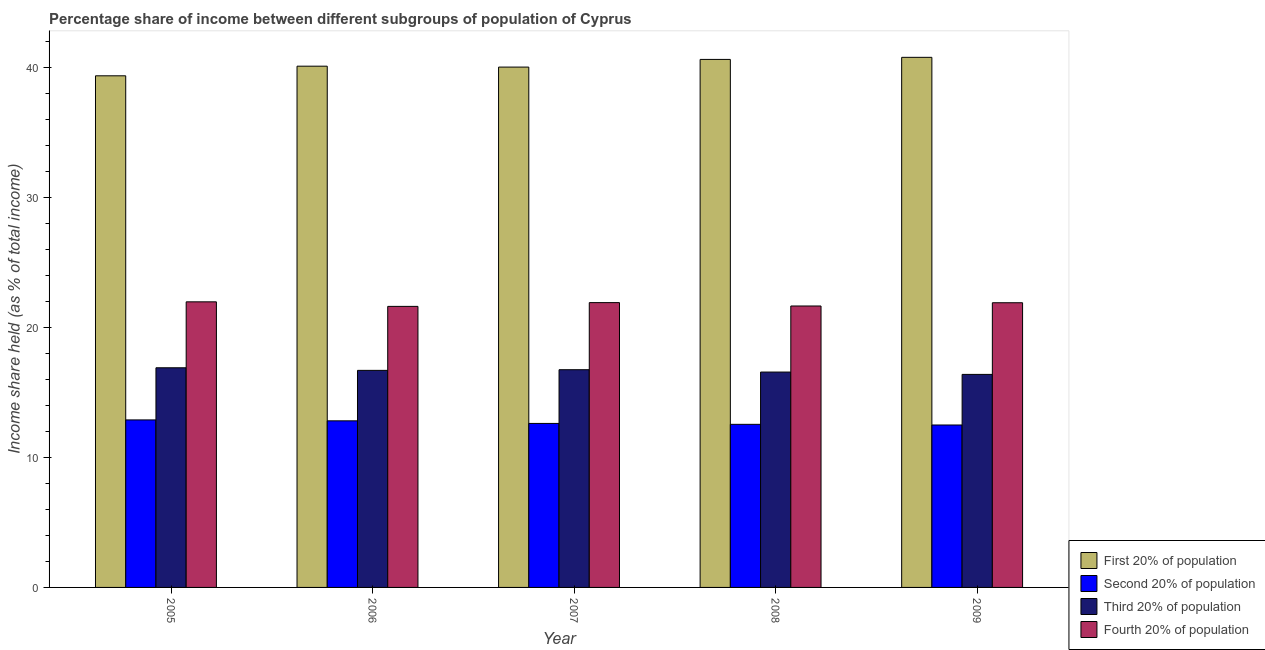How many groups of bars are there?
Give a very brief answer. 5. Are the number of bars on each tick of the X-axis equal?
Offer a terse response. Yes. How many bars are there on the 1st tick from the left?
Your response must be concise. 4. In how many cases, is the number of bars for a given year not equal to the number of legend labels?
Offer a terse response. 0. What is the share of the income held by fourth 20% of the population in 2009?
Provide a succinct answer. 21.89. Across all years, what is the maximum share of the income held by second 20% of the population?
Offer a very short reply. 12.88. Across all years, what is the minimum share of the income held by third 20% of the population?
Keep it short and to the point. 16.38. In which year was the share of the income held by third 20% of the population maximum?
Your answer should be compact. 2005. In which year was the share of the income held by third 20% of the population minimum?
Provide a succinct answer. 2009. What is the total share of the income held by second 20% of the population in the graph?
Your answer should be very brief. 63.33. What is the difference between the share of the income held by third 20% of the population in 2006 and that in 2008?
Your response must be concise. 0.13. What is the difference between the share of the income held by second 20% of the population in 2005 and the share of the income held by third 20% of the population in 2009?
Provide a succinct answer. 0.39. What is the average share of the income held by fourth 20% of the population per year?
Make the answer very short. 21.8. In the year 2007, what is the difference between the share of the income held by fourth 20% of the population and share of the income held by third 20% of the population?
Your answer should be very brief. 0. In how many years, is the share of the income held by first 20% of the population greater than 38 %?
Provide a short and direct response. 5. What is the ratio of the share of the income held by second 20% of the population in 2006 to that in 2008?
Provide a succinct answer. 1.02. Is the difference between the share of the income held by second 20% of the population in 2005 and 2008 greater than the difference between the share of the income held by first 20% of the population in 2005 and 2008?
Give a very brief answer. No. What is the difference between the highest and the second highest share of the income held by third 20% of the population?
Ensure brevity in your answer.  0.15. What is the difference between the highest and the lowest share of the income held by first 20% of the population?
Your answer should be very brief. 1.42. In how many years, is the share of the income held by fourth 20% of the population greater than the average share of the income held by fourth 20% of the population taken over all years?
Your answer should be very brief. 3. Is it the case that in every year, the sum of the share of the income held by first 20% of the population and share of the income held by second 20% of the population is greater than the sum of share of the income held by fourth 20% of the population and share of the income held by third 20% of the population?
Make the answer very short. Yes. What does the 2nd bar from the left in 2005 represents?
Provide a succinct answer. Second 20% of population. What does the 1st bar from the right in 2005 represents?
Keep it short and to the point. Fourth 20% of population. What is the difference between two consecutive major ticks on the Y-axis?
Offer a terse response. 10. Are the values on the major ticks of Y-axis written in scientific E-notation?
Your answer should be very brief. No. Does the graph contain any zero values?
Give a very brief answer. No. Does the graph contain grids?
Provide a short and direct response. No. Where does the legend appear in the graph?
Offer a very short reply. Bottom right. How are the legend labels stacked?
Offer a terse response. Vertical. What is the title of the graph?
Ensure brevity in your answer.  Percentage share of income between different subgroups of population of Cyprus. What is the label or title of the Y-axis?
Provide a short and direct response. Income share held (as % of total income). What is the Income share held (as % of total income) in First 20% of population in 2005?
Your answer should be very brief. 39.34. What is the Income share held (as % of total income) of Second 20% of population in 2005?
Provide a short and direct response. 12.88. What is the Income share held (as % of total income) of Third 20% of population in 2005?
Your answer should be compact. 16.89. What is the Income share held (as % of total income) of Fourth 20% of population in 2005?
Keep it short and to the point. 21.96. What is the Income share held (as % of total income) of First 20% of population in 2006?
Offer a very short reply. 40.08. What is the Income share held (as % of total income) in Second 20% of population in 2006?
Make the answer very short. 12.81. What is the Income share held (as % of total income) in Third 20% of population in 2006?
Keep it short and to the point. 16.69. What is the Income share held (as % of total income) in Fourth 20% of population in 2006?
Offer a very short reply. 21.61. What is the Income share held (as % of total income) in First 20% of population in 2007?
Your answer should be compact. 40.01. What is the Income share held (as % of total income) in Second 20% of population in 2007?
Offer a terse response. 12.61. What is the Income share held (as % of total income) in Third 20% of population in 2007?
Give a very brief answer. 16.74. What is the Income share held (as % of total income) of Fourth 20% of population in 2007?
Provide a short and direct response. 21.9. What is the Income share held (as % of total income) in First 20% of population in 2008?
Offer a very short reply. 40.6. What is the Income share held (as % of total income) in Second 20% of population in 2008?
Provide a succinct answer. 12.54. What is the Income share held (as % of total income) in Third 20% of population in 2008?
Give a very brief answer. 16.56. What is the Income share held (as % of total income) in Fourth 20% of population in 2008?
Provide a succinct answer. 21.64. What is the Income share held (as % of total income) of First 20% of population in 2009?
Provide a short and direct response. 40.76. What is the Income share held (as % of total income) in Second 20% of population in 2009?
Offer a very short reply. 12.49. What is the Income share held (as % of total income) in Third 20% of population in 2009?
Ensure brevity in your answer.  16.38. What is the Income share held (as % of total income) in Fourth 20% of population in 2009?
Keep it short and to the point. 21.89. Across all years, what is the maximum Income share held (as % of total income) in First 20% of population?
Keep it short and to the point. 40.76. Across all years, what is the maximum Income share held (as % of total income) in Second 20% of population?
Provide a succinct answer. 12.88. Across all years, what is the maximum Income share held (as % of total income) in Third 20% of population?
Your response must be concise. 16.89. Across all years, what is the maximum Income share held (as % of total income) of Fourth 20% of population?
Your answer should be compact. 21.96. Across all years, what is the minimum Income share held (as % of total income) in First 20% of population?
Your answer should be very brief. 39.34. Across all years, what is the minimum Income share held (as % of total income) in Second 20% of population?
Your answer should be compact. 12.49. Across all years, what is the minimum Income share held (as % of total income) of Third 20% of population?
Offer a very short reply. 16.38. Across all years, what is the minimum Income share held (as % of total income) in Fourth 20% of population?
Your response must be concise. 21.61. What is the total Income share held (as % of total income) of First 20% of population in the graph?
Your answer should be very brief. 200.79. What is the total Income share held (as % of total income) of Second 20% of population in the graph?
Offer a terse response. 63.33. What is the total Income share held (as % of total income) in Third 20% of population in the graph?
Your answer should be very brief. 83.26. What is the total Income share held (as % of total income) in Fourth 20% of population in the graph?
Your answer should be compact. 109. What is the difference between the Income share held (as % of total income) in First 20% of population in 2005 and that in 2006?
Offer a terse response. -0.74. What is the difference between the Income share held (as % of total income) in Second 20% of population in 2005 and that in 2006?
Your answer should be compact. 0.07. What is the difference between the Income share held (as % of total income) of Third 20% of population in 2005 and that in 2006?
Keep it short and to the point. 0.2. What is the difference between the Income share held (as % of total income) of Fourth 20% of population in 2005 and that in 2006?
Your answer should be compact. 0.35. What is the difference between the Income share held (as % of total income) of First 20% of population in 2005 and that in 2007?
Offer a terse response. -0.67. What is the difference between the Income share held (as % of total income) of Second 20% of population in 2005 and that in 2007?
Offer a very short reply. 0.27. What is the difference between the Income share held (as % of total income) in Fourth 20% of population in 2005 and that in 2007?
Offer a very short reply. 0.06. What is the difference between the Income share held (as % of total income) in First 20% of population in 2005 and that in 2008?
Your answer should be very brief. -1.26. What is the difference between the Income share held (as % of total income) of Second 20% of population in 2005 and that in 2008?
Keep it short and to the point. 0.34. What is the difference between the Income share held (as % of total income) in Third 20% of population in 2005 and that in 2008?
Provide a short and direct response. 0.33. What is the difference between the Income share held (as % of total income) in Fourth 20% of population in 2005 and that in 2008?
Offer a terse response. 0.32. What is the difference between the Income share held (as % of total income) in First 20% of population in 2005 and that in 2009?
Offer a terse response. -1.42. What is the difference between the Income share held (as % of total income) of Second 20% of population in 2005 and that in 2009?
Your response must be concise. 0.39. What is the difference between the Income share held (as % of total income) in Third 20% of population in 2005 and that in 2009?
Provide a short and direct response. 0.51. What is the difference between the Income share held (as % of total income) of Fourth 20% of population in 2005 and that in 2009?
Give a very brief answer. 0.07. What is the difference between the Income share held (as % of total income) of First 20% of population in 2006 and that in 2007?
Offer a terse response. 0.07. What is the difference between the Income share held (as % of total income) in Second 20% of population in 2006 and that in 2007?
Your answer should be very brief. 0.2. What is the difference between the Income share held (as % of total income) in Third 20% of population in 2006 and that in 2007?
Provide a short and direct response. -0.05. What is the difference between the Income share held (as % of total income) in Fourth 20% of population in 2006 and that in 2007?
Ensure brevity in your answer.  -0.29. What is the difference between the Income share held (as % of total income) in First 20% of population in 2006 and that in 2008?
Your answer should be compact. -0.52. What is the difference between the Income share held (as % of total income) in Second 20% of population in 2006 and that in 2008?
Offer a terse response. 0.27. What is the difference between the Income share held (as % of total income) of Third 20% of population in 2006 and that in 2008?
Give a very brief answer. 0.13. What is the difference between the Income share held (as % of total income) in Fourth 20% of population in 2006 and that in 2008?
Offer a terse response. -0.03. What is the difference between the Income share held (as % of total income) in First 20% of population in 2006 and that in 2009?
Your answer should be compact. -0.68. What is the difference between the Income share held (as % of total income) in Second 20% of population in 2006 and that in 2009?
Make the answer very short. 0.32. What is the difference between the Income share held (as % of total income) in Third 20% of population in 2006 and that in 2009?
Make the answer very short. 0.31. What is the difference between the Income share held (as % of total income) of Fourth 20% of population in 2006 and that in 2009?
Keep it short and to the point. -0.28. What is the difference between the Income share held (as % of total income) of First 20% of population in 2007 and that in 2008?
Your answer should be very brief. -0.59. What is the difference between the Income share held (as % of total income) in Second 20% of population in 2007 and that in 2008?
Offer a terse response. 0.07. What is the difference between the Income share held (as % of total income) in Third 20% of population in 2007 and that in 2008?
Ensure brevity in your answer.  0.18. What is the difference between the Income share held (as % of total income) of Fourth 20% of population in 2007 and that in 2008?
Keep it short and to the point. 0.26. What is the difference between the Income share held (as % of total income) of First 20% of population in 2007 and that in 2009?
Your answer should be compact. -0.75. What is the difference between the Income share held (as % of total income) in Second 20% of population in 2007 and that in 2009?
Provide a succinct answer. 0.12. What is the difference between the Income share held (as % of total income) of Third 20% of population in 2007 and that in 2009?
Provide a short and direct response. 0.36. What is the difference between the Income share held (as % of total income) of Fourth 20% of population in 2007 and that in 2009?
Provide a succinct answer. 0.01. What is the difference between the Income share held (as % of total income) in First 20% of population in 2008 and that in 2009?
Make the answer very short. -0.16. What is the difference between the Income share held (as % of total income) in Third 20% of population in 2008 and that in 2009?
Your answer should be compact. 0.18. What is the difference between the Income share held (as % of total income) of Fourth 20% of population in 2008 and that in 2009?
Give a very brief answer. -0.25. What is the difference between the Income share held (as % of total income) of First 20% of population in 2005 and the Income share held (as % of total income) of Second 20% of population in 2006?
Offer a terse response. 26.53. What is the difference between the Income share held (as % of total income) in First 20% of population in 2005 and the Income share held (as % of total income) in Third 20% of population in 2006?
Your answer should be compact. 22.65. What is the difference between the Income share held (as % of total income) in First 20% of population in 2005 and the Income share held (as % of total income) in Fourth 20% of population in 2006?
Keep it short and to the point. 17.73. What is the difference between the Income share held (as % of total income) of Second 20% of population in 2005 and the Income share held (as % of total income) of Third 20% of population in 2006?
Offer a terse response. -3.81. What is the difference between the Income share held (as % of total income) in Second 20% of population in 2005 and the Income share held (as % of total income) in Fourth 20% of population in 2006?
Give a very brief answer. -8.73. What is the difference between the Income share held (as % of total income) in Third 20% of population in 2005 and the Income share held (as % of total income) in Fourth 20% of population in 2006?
Offer a terse response. -4.72. What is the difference between the Income share held (as % of total income) in First 20% of population in 2005 and the Income share held (as % of total income) in Second 20% of population in 2007?
Your answer should be very brief. 26.73. What is the difference between the Income share held (as % of total income) of First 20% of population in 2005 and the Income share held (as % of total income) of Third 20% of population in 2007?
Your answer should be very brief. 22.6. What is the difference between the Income share held (as % of total income) in First 20% of population in 2005 and the Income share held (as % of total income) in Fourth 20% of population in 2007?
Keep it short and to the point. 17.44. What is the difference between the Income share held (as % of total income) of Second 20% of population in 2005 and the Income share held (as % of total income) of Third 20% of population in 2007?
Provide a succinct answer. -3.86. What is the difference between the Income share held (as % of total income) of Second 20% of population in 2005 and the Income share held (as % of total income) of Fourth 20% of population in 2007?
Your answer should be very brief. -9.02. What is the difference between the Income share held (as % of total income) in Third 20% of population in 2005 and the Income share held (as % of total income) in Fourth 20% of population in 2007?
Provide a short and direct response. -5.01. What is the difference between the Income share held (as % of total income) in First 20% of population in 2005 and the Income share held (as % of total income) in Second 20% of population in 2008?
Make the answer very short. 26.8. What is the difference between the Income share held (as % of total income) of First 20% of population in 2005 and the Income share held (as % of total income) of Third 20% of population in 2008?
Keep it short and to the point. 22.78. What is the difference between the Income share held (as % of total income) in Second 20% of population in 2005 and the Income share held (as % of total income) in Third 20% of population in 2008?
Offer a very short reply. -3.68. What is the difference between the Income share held (as % of total income) of Second 20% of population in 2005 and the Income share held (as % of total income) of Fourth 20% of population in 2008?
Keep it short and to the point. -8.76. What is the difference between the Income share held (as % of total income) of Third 20% of population in 2005 and the Income share held (as % of total income) of Fourth 20% of population in 2008?
Offer a very short reply. -4.75. What is the difference between the Income share held (as % of total income) in First 20% of population in 2005 and the Income share held (as % of total income) in Second 20% of population in 2009?
Ensure brevity in your answer.  26.85. What is the difference between the Income share held (as % of total income) of First 20% of population in 2005 and the Income share held (as % of total income) of Third 20% of population in 2009?
Provide a short and direct response. 22.96. What is the difference between the Income share held (as % of total income) in First 20% of population in 2005 and the Income share held (as % of total income) in Fourth 20% of population in 2009?
Your answer should be compact. 17.45. What is the difference between the Income share held (as % of total income) of Second 20% of population in 2005 and the Income share held (as % of total income) of Fourth 20% of population in 2009?
Offer a very short reply. -9.01. What is the difference between the Income share held (as % of total income) of Third 20% of population in 2005 and the Income share held (as % of total income) of Fourth 20% of population in 2009?
Provide a succinct answer. -5. What is the difference between the Income share held (as % of total income) of First 20% of population in 2006 and the Income share held (as % of total income) of Second 20% of population in 2007?
Make the answer very short. 27.47. What is the difference between the Income share held (as % of total income) of First 20% of population in 2006 and the Income share held (as % of total income) of Third 20% of population in 2007?
Offer a terse response. 23.34. What is the difference between the Income share held (as % of total income) of First 20% of population in 2006 and the Income share held (as % of total income) of Fourth 20% of population in 2007?
Provide a succinct answer. 18.18. What is the difference between the Income share held (as % of total income) of Second 20% of population in 2006 and the Income share held (as % of total income) of Third 20% of population in 2007?
Your response must be concise. -3.93. What is the difference between the Income share held (as % of total income) of Second 20% of population in 2006 and the Income share held (as % of total income) of Fourth 20% of population in 2007?
Provide a succinct answer. -9.09. What is the difference between the Income share held (as % of total income) in Third 20% of population in 2006 and the Income share held (as % of total income) in Fourth 20% of population in 2007?
Provide a short and direct response. -5.21. What is the difference between the Income share held (as % of total income) in First 20% of population in 2006 and the Income share held (as % of total income) in Second 20% of population in 2008?
Make the answer very short. 27.54. What is the difference between the Income share held (as % of total income) in First 20% of population in 2006 and the Income share held (as % of total income) in Third 20% of population in 2008?
Make the answer very short. 23.52. What is the difference between the Income share held (as % of total income) in First 20% of population in 2006 and the Income share held (as % of total income) in Fourth 20% of population in 2008?
Provide a succinct answer. 18.44. What is the difference between the Income share held (as % of total income) in Second 20% of population in 2006 and the Income share held (as % of total income) in Third 20% of population in 2008?
Provide a short and direct response. -3.75. What is the difference between the Income share held (as % of total income) in Second 20% of population in 2006 and the Income share held (as % of total income) in Fourth 20% of population in 2008?
Ensure brevity in your answer.  -8.83. What is the difference between the Income share held (as % of total income) of Third 20% of population in 2006 and the Income share held (as % of total income) of Fourth 20% of population in 2008?
Keep it short and to the point. -4.95. What is the difference between the Income share held (as % of total income) of First 20% of population in 2006 and the Income share held (as % of total income) of Second 20% of population in 2009?
Offer a very short reply. 27.59. What is the difference between the Income share held (as % of total income) of First 20% of population in 2006 and the Income share held (as % of total income) of Third 20% of population in 2009?
Ensure brevity in your answer.  23.7. What is the difference between the Income share held (as % of total income) of First 20% of population in 2006 and the Income share held (as % of total income) of Fourth 20% of population in 2009?
Offer a very short reply. 18.19. What is the difference between the Income share held (as % of total income) of Second 20% of population in 2006 and the Income share held (as % of total income) of Third 20% of population in 2009?
Provide a succinct answer. -3.57. What is the difference between the Income share held (as % of total income) in Second 20% of population in 2006 and the Income share held (as % of total income) in Fourth 20% of population in 2009?
Your response must be concise. -9.08. What is the difference between the Income share held (as % of total income) of Third 20% of population in 2006 and the Income share held (as % of total income) of Fourth 20% of population in 2009?
Ensure brevity in your answer.  -5.2. What is the difference between the Income share held (as % of total income) in First 20% of population in 2007 and the Income share held (as % of total income) in Second 20% of population in 2008?
Your answer should be very brief. 27.47. What is the difference between the Income share held (as % of total income) of First 20% of population in 2007 and the Income share held (as % of total income) of Third 20% of population in 2008?
Give a very brief answer. 23.45. What is the difference between the Income share held (as % of total income) in First 20% of population in 2007 and the Income share held (as % of total income) in Fourth 20% of population in 2008?
Provide a succinct answer. 18.37. What is the difference between the Income share held (as % of total income) in Second 20% of population in 2007 and the Income share held (as % of total income) in Third 20% of population in 2008?
Ensure brevity in your answer.  -3.95. What is the difference between the Income share held (as % of total income) of Second 20% of population in 2007 and the Income share held (as % of total income) of Fourth 20% of population in 2008?
Make the answer very short. -9.03. What is the difference between the Income share held (as % of total income) of First 20% of population in 2007 and the Income share held (as % of total income) of Second 20% of population in 2009?
Give a very brief answer. 27.52. What is the difference between the Income share held (as % of total income) of First 20% of population in 2007 and the Income share held (as % of total income) of Third 20% of population in 2009?
Your response must be concise. 23.63. What is the difference between the Income share held (as % of total income) of First 20% of population in 2007 and the Income share held (as % of total income) of Fourth 20% of population in 2009?
Provide a succinct answer. 18.12. What is the difference between the Income share held (as % of total income) of Second 20% of population in 2007 and the Income share held (as % of total income) of Third 20% of population in 2009?
Ensure brevity in your answer.  -3.77. What is the difference between the Income share held (as % of total income) in Second 20% of population in 2007 and the Income share held (as % of total income) in Fourth 20% of population in 2009?
Offer a very short reply. -9.28. What is the difference between the Income share held (as % of total income) in Third 20% of population in 2007 and the Income share held (as % of total income) in Fourth 20% of population in 2009?
Provide a short and direct response. -5.15. What is the difference between the Income share held (as % of total income) of First 20% of population in 2008 and the Income share held (as % of total income) of Second 20% of population in 2009?
Provide a succinct answer. 28.11. What is the difference between the Income share held (as % of total income) in First 20% of population in 2008 and the Income share held (as % of total income) in Third 20% of population in 2009?
Your answer should be very brief. 24.22. What is the difference between the Income share held (as % of total income) of First 20% of population in 2008 and the Income share held (as % of total income) of Fourth 20% of population in 2009?
Make the answer very short. 18.71. What is the difference between the Income share held (as % of total income) of Second 20% of population in 2008 and the Income share held (as % of total income) of Third 20% of population in 2009?
Offer a terse response. -3.84. What is the difference between the Income share held (as % of total income) of Second 20% of population in 2008 and the Income share held (as % of total income) of Fourth 20% of population in 2009?
Make the answer very short. -9.35. What is the difference between the Income share held (as % of total income) in Third 20% of population in 2008 and the Income share held (as % of total income) in Fourth 20% of population in 2009?
Your answer should be very brief. -5.33. What is the average Income share held (as % of total income) in First 20% of population per year?
Give a very brief answer. 40.16. What is the average Income share held (as % of total income) of Second 20% of population per year?
Keep it short and to the point. 12.67. What is the average Income share held (as % of total income) of Third 20% of population per year?
Your answer should be compact. 16.65. What is the average Income share held (as % of total income) in Fourth 20% of population per year?
Your answer should be very brief. 21.8. In the year 2005, what is the difference between the Income share held (as % of total income) in First 20% of population and Income share held (as % of total income) in Second 20% of population?
Keep it short and to the point. 26.46. In the year 2005, what is the difference between the Income share held (as % of total income) in First 20% of population and Income share held (as % of total income) in Third 20% of population?
Offer a terse response. 22.45. In the year 2005, what is the difference between the Income share held (as % of total income) in First 20% of population and Income share held (as % of total income) in Fourth 20% of population?
Keep it short and to the point. 17.38. In the year 2005, what is the difference between the Income share held (as % of total income) in Second 20% of population and Income share held (as % of total income) in Third 20% of population?
Offer a terse response. -4.01. In the year 2005, what is the difference between the Income share held (as % of total income) of Second 20% of population and Income share held (as % of total income) of Fourth 20% of population?
Offer a very short reply. -9.08. In the year 2005, what is the difference between the Income share held (as % of total income) in Third 20% of population and Income share held (as % of total income) in Fourth 20% of population?
Make the answer very short. -5.07. In the year 2006, what is the difference between the Income share held (as % of total income) of First 20% of population and Income share held (as % of total income) of Second 20% of population?
Give a very brief answer. 27.27. In the year 2006, what is the difference between the Income share held (as % of total income) in First 20% of population and Income share held (as % of total income) in Third 20% of population?
Offer a very short reply. 23.39. In the year 2006, what is the difference between the Income share held (as % of total income) in First 20% of population and Income share held (as % of total income) in Fourth 20% of population?
Your response must be concise. 18.47. In the year 2006, what is the difference between the Income share held (as % of total income) of Second 20% of population and Income share held (as % of total income) of Third 20% of population?
Provide a short and direct response. -3.88. In the year 2006, what is the difference between the Income share held (as % of total income) in Second 20% of population and Income share held (as % of total income) in Fourth 20% of population?
Give a very brief answer. -8.8. In the year 2006, what is the difference between the Income share held (as % of total income) in Third 20% of population and Income share held (as % of total income) in Fourth 20% of population?
Your response must be concise. -4.92. In the year 2007, what is the difference between the Income share held (as % of total income) of First 20% of population and Income share held (as % of total income) of Second 20% of population?
Your answer should be very brief. 27.4. In the year 2007, what is the difference between the Income share held (as % of total income) in First 20% of population and Income share held (as % of total income) in Third 20% of population?
Offer a terse response. 23.27. In the year 2007, what is the difference between the Income share held (as % of total income) in First 20% of population and Income share held (as % of total income) in Fourth 20% of population?
Provide a succinct answer. 18.11. In the year 2007, what is the difference between the Income share held (as % of total income) of Second 20% of population and Income share held (as % of total income) of Third 20% of population?
Your answer should be compact. -4.13. In the year 2007, what is the difference between the Income share held (as % of total income) of Second 20% of population and Income share held (as % of total income) of Fourth 20% of population?
Offer a very short reply. -9.29. In the year 2007, what is the difference between the Income share held (as % of total income) of Third 20% of population and Income share held (as % of total income) of Fourth 20% of population?
Your answer should be compact. -5.16. In the year 2008, what is the difference between the Income share held (as % of total income) in First 20% of population and Income share held (as % of total income) in Second 20% of population?
Your response must be concise. 28.06. In the year 2008, what is the difference between the Income share held (as % of total income) of First 20% of population and Income share held (as % of total income) of Third 20% of population?
Your answer should be compact. 24.04. In the year 2008, what is the difference between the Income share held (as % of total income) of First 20% of population and Income share held (as % of total income) of Fourth 20% of population?
Offer a terse response. 18.96. In the year 2008, what is the difference between the Income share held (as % of total income) in Second 20% of population and Income share held (as % of total income) in Third 20% of population?
Offer a very short reply. -4.02. In the year 2008, what is the difference between the Income share held (as % of total income) in Second 20% of population and Income share held (as % of total income) in Fourth 20% of population?
Ensure brevity in your answer.  -9.1. In the year 2008, what is the difference between the Income share held (as % of total income) in Third 20% of population and Income share held (as % of total income) in Fourth 20% of population?
Offer a terse response. -5.08. In the year 2009, what is the difference between the Income share held (as % of total income) in First 20% of population and Income share held (as % of total income) in Second 20% of population?
Keep it short and to the point. 28.27. In the year 2009, what is the difference between the Income share held (as % of total income) in First 20% of population and Income share held (as % of total income) in Third 20% of population?
Make the answer very short. 24.38. In the year 2009, what is the difference between the Income share held (as % of total income) of First 20% of population and Income share held (as % of total income) of Fourth 20% of population?
Keep it short and to the point. 18.87. In the year 2009, what is the difference between the Income share held (as % of total income) of Second 20% of population and Income share held (as % of total income) of Third 20% of population?
Ensure brevity in your answer.  -3.89. In the year 2009, what is the difference between the Income share held (as % of total income) in Second 20% of population and Income share held (as % of total income) in Fourth 20% of population?
Your answer should be compact. -9.4. In the year 2009, what is the difference between the Income share held (as % of total income) of Third 20% of population and Income share held (as % of total income) of Fourth 20% of population?
Provide a short and direct response. -5.51. What is the ratio of the Income share held (as % of total income) of First 20% of population in 2005 to that in 2006?
Your answer should be very brief. 0.98. What is the ratio of the Income share held (as % of total income) in Second 20% of population in 2005 to that in 2006?
Your answer should be very brief. 1.01. What is the ratio of the Income share held (as % of total income) in Third 20% of population in 2005 to that in 2006?
Offer a terse response. 1.01. What is the ratio of the Income share held (as % of total income) of Fourth 20% of population in 2005 to that in 2006?
Your response must be concise. 1.02. What is the ratio of the Income share held (as % of total income) of First 20% of population in 2005 to that in 2007?
Your response must be concise. 0.98. What is the ratio of the Income share held (as % of total income) in Second 20% of population in 2005 to that in 2007?
Your answer should be compact. 1.02. What is the ratio of the Income share held (as % of total income) in Fourth 20% of population in 2005 to that in 2007?
Your response must be concise. 1. What is the ratio of the Income share held (as % of total income) of Second 20% of population in 2005 to that in 2008?
Ensure brevity in your answer.  1.03. What is the ratio of the Income share held (as % of total income) of Third 20% of population in 2005 to that in 2008?
Your response must be concise. 1.02. What is the ratio of the Income share held (as % of total income) in Fourth 20% of population in 2005 to that in 2008?
Offer a terse response. 1.01. What is the ratio of the Income share held (as % of total income) in First 20% of population in 2005 to that in 2009?
Offer a very short reply. 0.97. What is the ratio of the Income share held (as % of total income) of Second 20% of population in 2005 to that in 2009?
Your answer should be very brief. 1.03. What is the ratio of the Income share held (as % of total income) of Third 20% of population in 2005 to that in 2009?
Provide a short and direct response. 1.03. What is the ratio of the Income share held (as % of total income) of Fourth 20% of population in 2005 to that in 2009?
Offer a very short reply. 1. What is the ratio of the Income share held (as % of total income) of Second 20% of population in 2006 to that in 2007?
Make the answer very short. 1.02. What is the ratio of the Income share held (as % of total income) of Fourth 20% of population in 2006 to that in 2007?
Give a very brief answer. 0.99. What is the ratio of the Income share held (as % of total income) in First 20% of population in 2006 to that in 2008?
Ensure brevity in your answer.  0.99. What is the ratio of the Income share held (as % of total income) of Second 20% of population in 2006 to that in 2008?
Your answer should be compact. 1.02. What is the ratio of the Income share held (as % of total income) in Third 20% of population in 2006 to that in 2008?
Make the answer very short. 1.01. What is the ratio of the Income share held (as % of total income) of First 20% of population in 2006 to that in 2009?
Offer a terse response. 0.98. What is the ratio of the Income share held (as % of total income) in Second 20% of population in 2006 to that in 2009?
Ensure brevity in your answer.  1.03. What is the ratio of the Income share held (as % of total income) of Third 20% of population in 2006 to that in 2009?
Offer a very short reply. 1.02. What is the ratio of the Income share held (as % of total income) in Fourth 20% of population in 2006 to that in 2009?
Your answer should be very brief. 0.99. What is the ratio of the Income share held (as % of total income) of First 20% of population in 2007 to that in 2008?
Offer a terse response. 0.99. What is the ratio of the Income share held (as % of total income) of Second 20% of population in 2007 to that in 2008?
Ensure brevity in your answer.  1.01. What is the ratio of the Income share held (as % of total income) in Third 20% of population in 2007 to that in 2008?
Keep it short and to the point. 1.01. What is the ratio of the Income share held (as % of total income) of Fourth 20% of population in 2007 to that in 2008?
Give a very brief answer. 1.01. What is the ratio of the Income share held (as % of total income) in First 20% of population in 2007 to that in 2009?
Your response must be concise. 0.98. What is the ratio of the Income share held (as % of total income) of Second 20% of population in 2007 to that in 2009?
Offer a terse response. 1.01. What is the ratio of the Income share held (as % of total income) in Third 20% of population in 2007 to that in 2009?
Provide a succinct answer. 1.02. What is the ratio of the Income share held (as % of total income) of Fourth 20% of population in 2007 to that in 2009?
Give a very brief answer. 1. What is the ratio of the Income share held (as % of total income) in Fourth 20% of population in 2008 to that in 2009?
Keep it short and to the point. 0.99. What is the difference between the highest and the second highest Income share held (as % of total income) of First 20% of population?
Offer a terse response. 0.16. What is the difference between the highest and the second highest Income share held (as % of total income) of Second 20% of population?
Ensure brevity in your answer.  0.07. What is the difference between the highest and the lowest Income share held (as % of total income) of First 20% of population?
Give a very brief answer. 1.42. What is the difference between the highest and the lowest Income share held (as % of total income) in Second 20% of population?
Your answer should be very brief. 0.39. What is the difference between the highest and the lowest Income share held (as % of total income) of Third 20% of population?
Offer a very short reply. 0.51. 